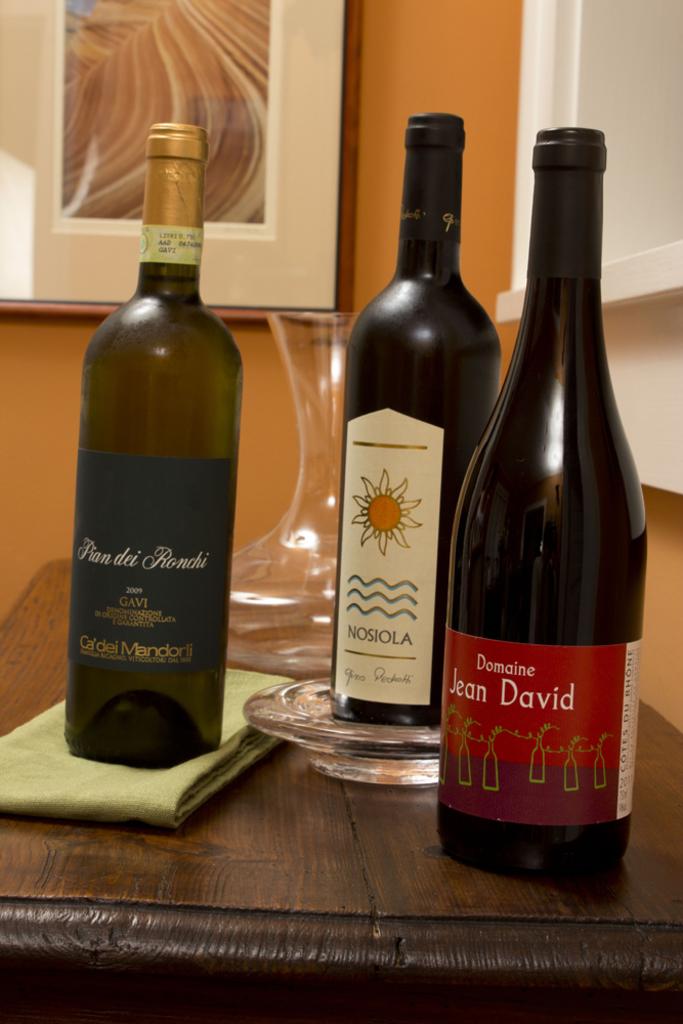What is the brand of these wines?
Your answer should be very brief. Domaine jean-david, nosiola, fian dei ronchi . What is the word above jean david?
Your response must be concise. Domaine. 